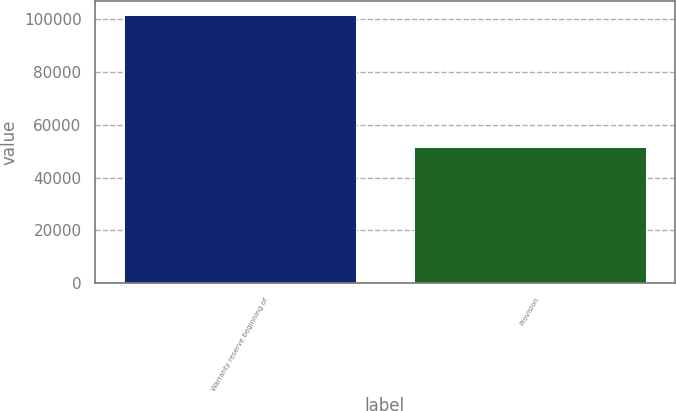Convert chart to OTSL. <chart><loc_0><loc_0><loc_500><loc_500><bar_chart><fcel>Warranty reserve beginning of<fcel>Provision<nl><fcel>101507<fcel>51668<nl></chart> 